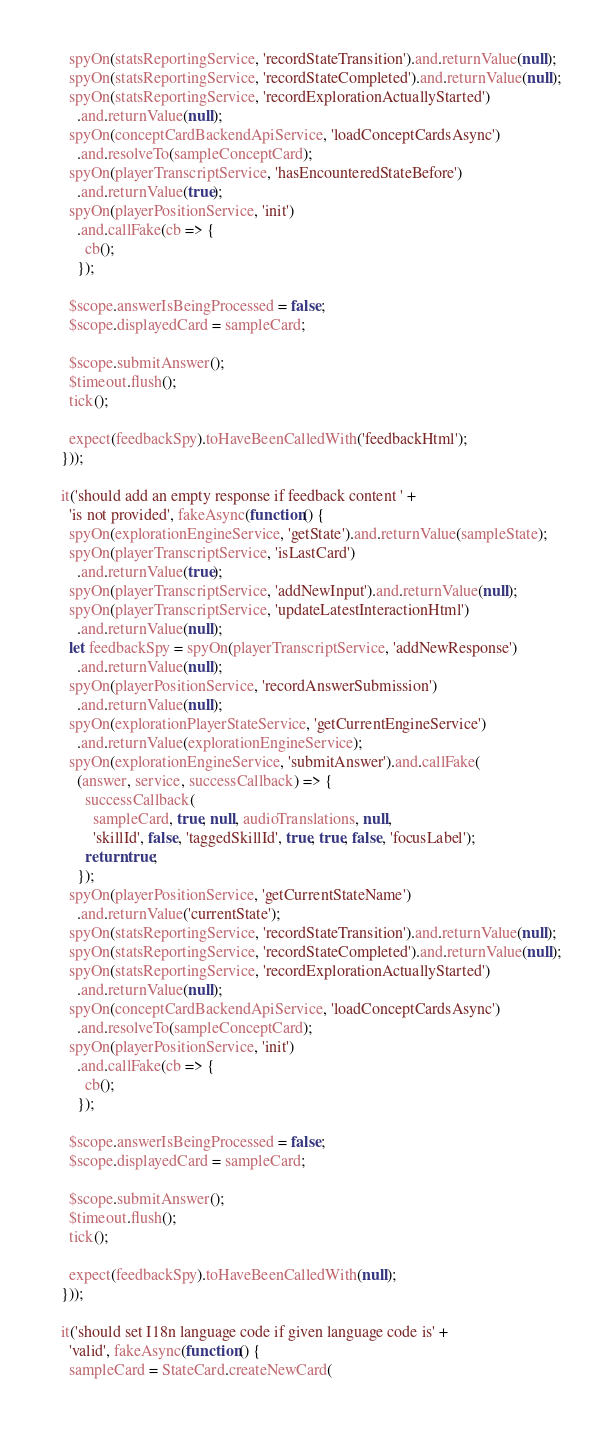Convert code to text. <code><loc_0><loc_0><loc_500><loc_500><_TypeScript_>    spyOn(statsReportingService, 'recordStateTransition').and.returnValue(null);
    spyOn(statsReportingService, 'recordStateCompleted').and.returnValue(null);
    spyOn(statsReportingService, 'recordExplorationActuallyStarted')
      .and.returnValue(null);
    spyOn(conceptCardBackendApiService, 'loadConceptCardsAsync')
      .and.resolveTo(sampleConceptCard);
    spyOn(playerTranscriptService, 'hasEncounteredStateBefore')
      .and.returnValue(true);
    spyOn(playerPositionService, 'init')
      .and.callFake(cb => {
        cb();
      });

    $scope.answerIsBeingProcessed = false;
    $scope.displayedCard = sampleCard;

    $scope.submitAnswer();
    $timeout.flush();
    tick();

    expect(feedbackSpy).toHaveBeenCalledWith('feedbackHtml');
  }));

  it('should add an empty response if feedback content ' +
    'is not provided', fakeAsync(function() {
    spyOn(explorationEngineService, 'getState').and.returnValue(sampleState);
    spyOn(playerTranscriptService, 'isLastCard')
      .and.returnValue(true);
    spyOn(playerTranscriptService, 'addNewInput').and.returnValue(null);
    spyOn(playerTranscriptService, 'updateLatestInteractionHtml')
      .and.returnValue(null);
    let feedbackSpy = spyOn(playerTranscriptService, 'addNewResponse')
      .and.returnValue(null);
    spyOn(playerPositionService, 'recordAnswerSubmission')
      .and.returnValue(null);
    spyOn(explorationPlayerStateService, 'getCurrentEngineService')
      .and.returnValue(explorationEngineService);
    spyOn(explorationEngineService, 'submitAnswer').and.callFake(
      (answer, service, successCallback) => {
        successCallback(
          sampleCard, true, null, audioTranslations, null,
          'skillId', false, 'taggedSkillId', true, true, false, 'focusLabel');
        return true;
      });
    spyOn(playerPositionService, 'getCurrentStateName')
      .and.returnValue('currentState');
    spyOn(statsReportingService, 'recordStateTransition').and.returnValue(null);
    spyOn(statsReportingService, 'recordStateCompleted').and.returnValue(null);
    spyOn(statsReportingService, 'recordExplorationActuallyStarted')
      .and.returnValue(null);
    spyOn(conceptCardBackendApiService, 'loadConceptCardsAsync')
      .and.resolveTo(sampleConceptCard);
    spyOn(playerPositionService, 'init')
      .and.callFake(cb => {
        cb();
      });

    $scope.answerIsBeingProcessed = false;
    $scope.displayedCard = sampleCard;

    $scope.submitAnswer();
    $timeout.flush();
    tick();

    expect(feedbackSpy).toHaveBeenCalledWith(null);
  }));

  it('should set I18n language code if given language code is' +
    'valid', fakeAsync(function() {
    sampleCard = StateCard.createNewCard(</code> 